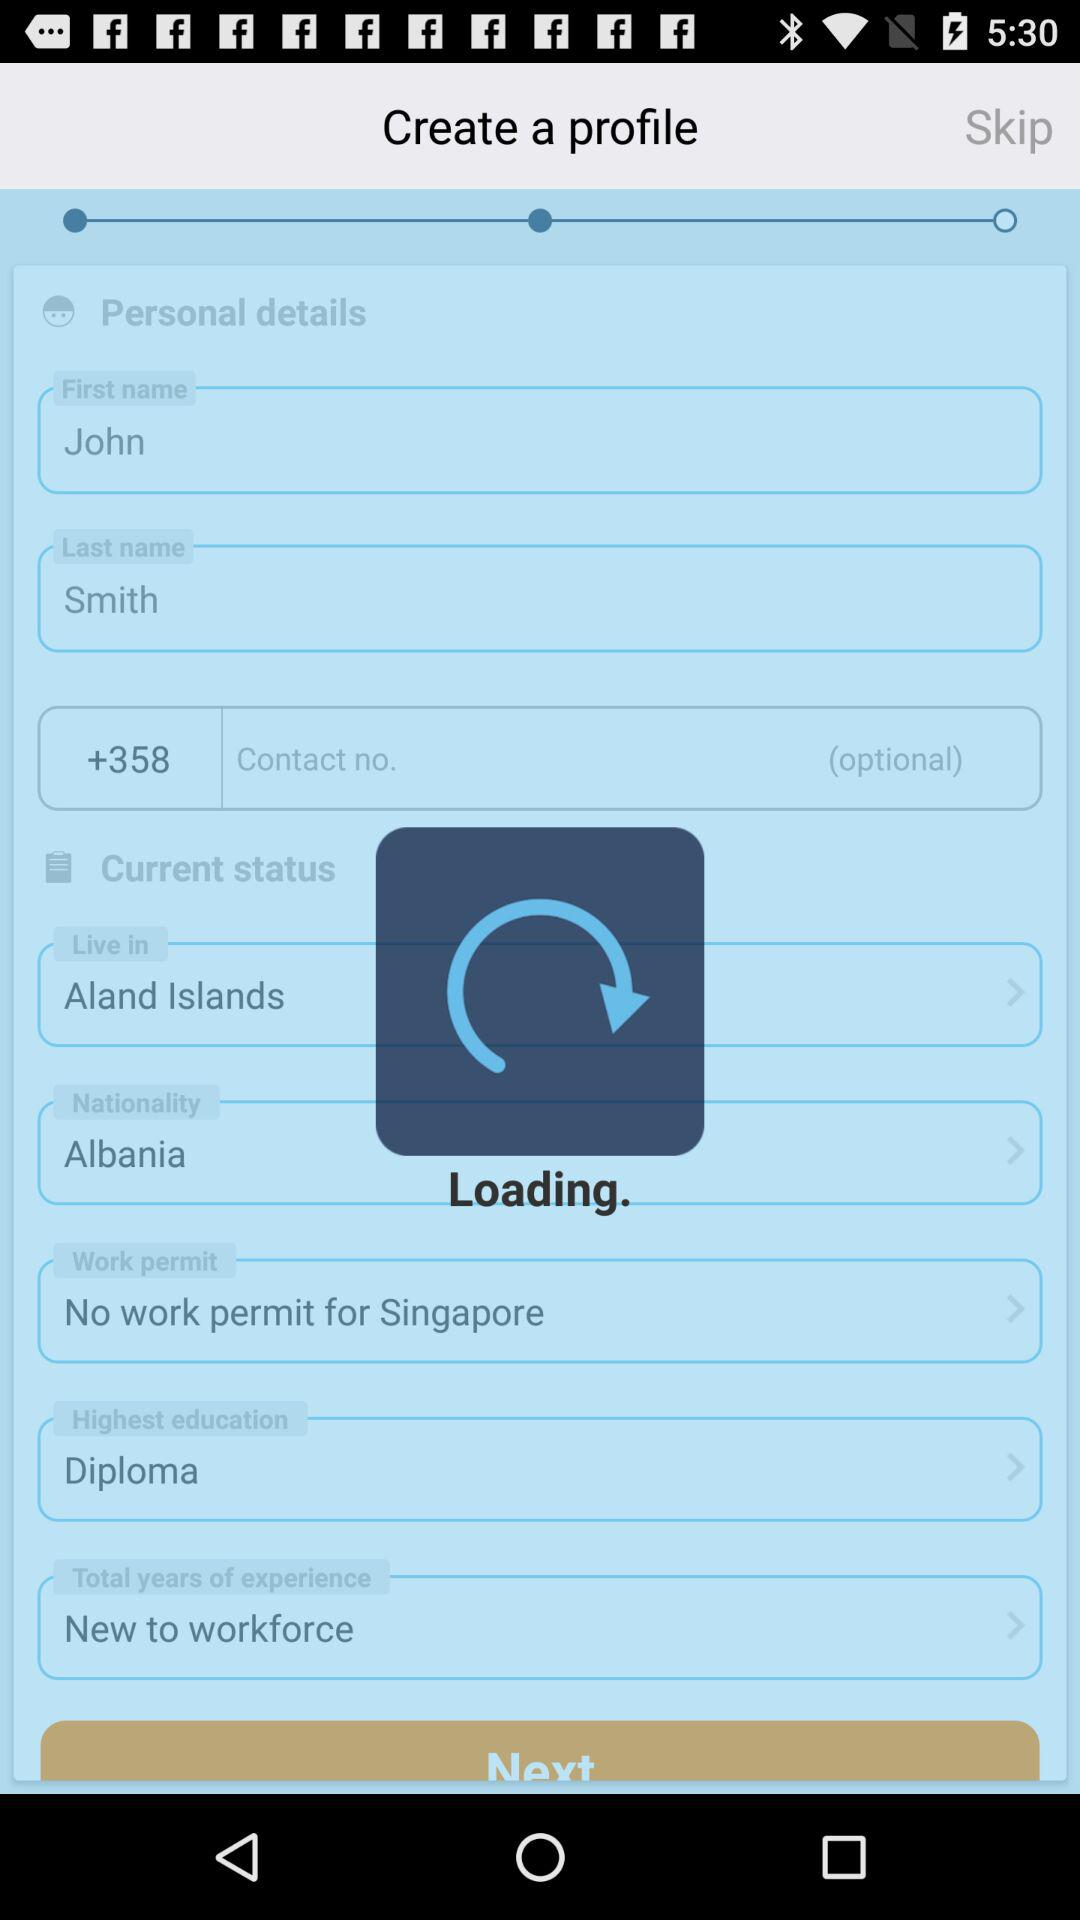Where does John Smith live? John Smith lives on the Aland Islands. 